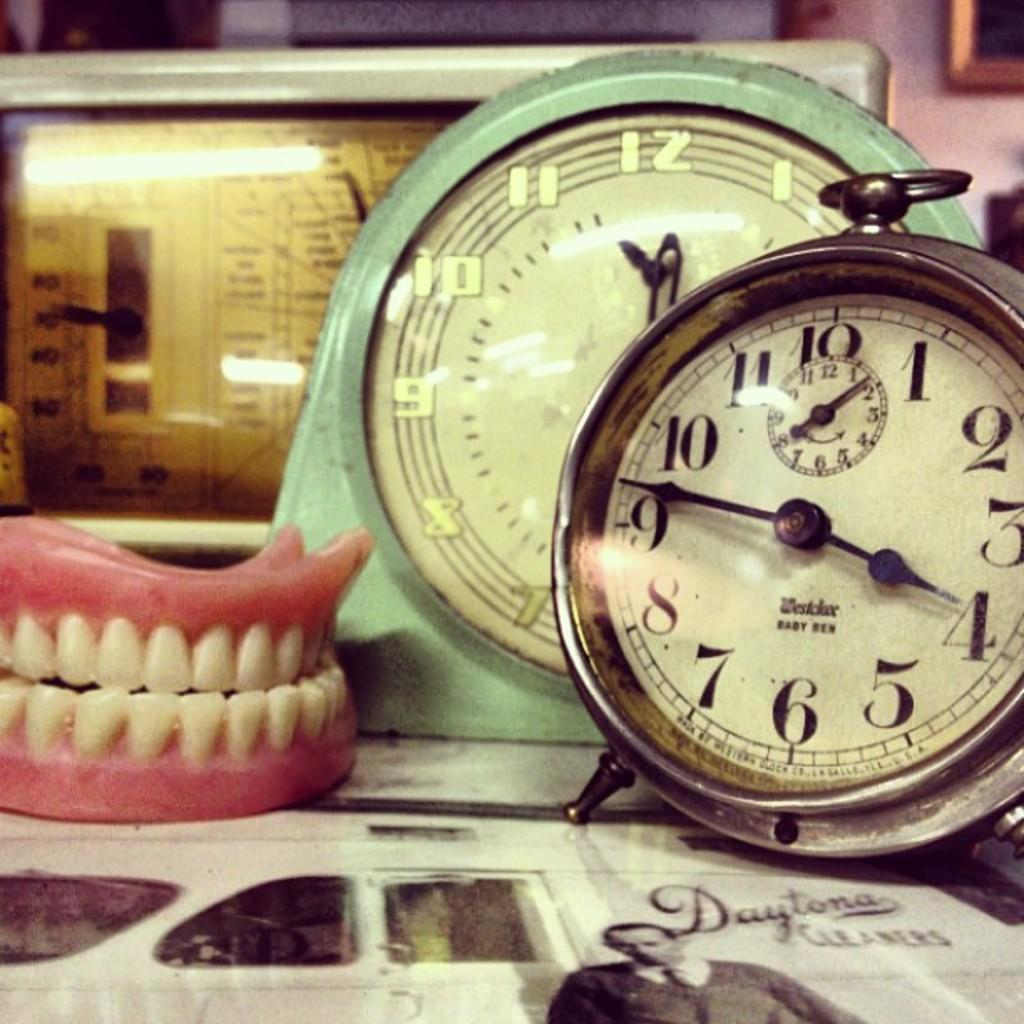<image>
Render a clear and concise summary of the photo. the number 12 is on the face of the clock 